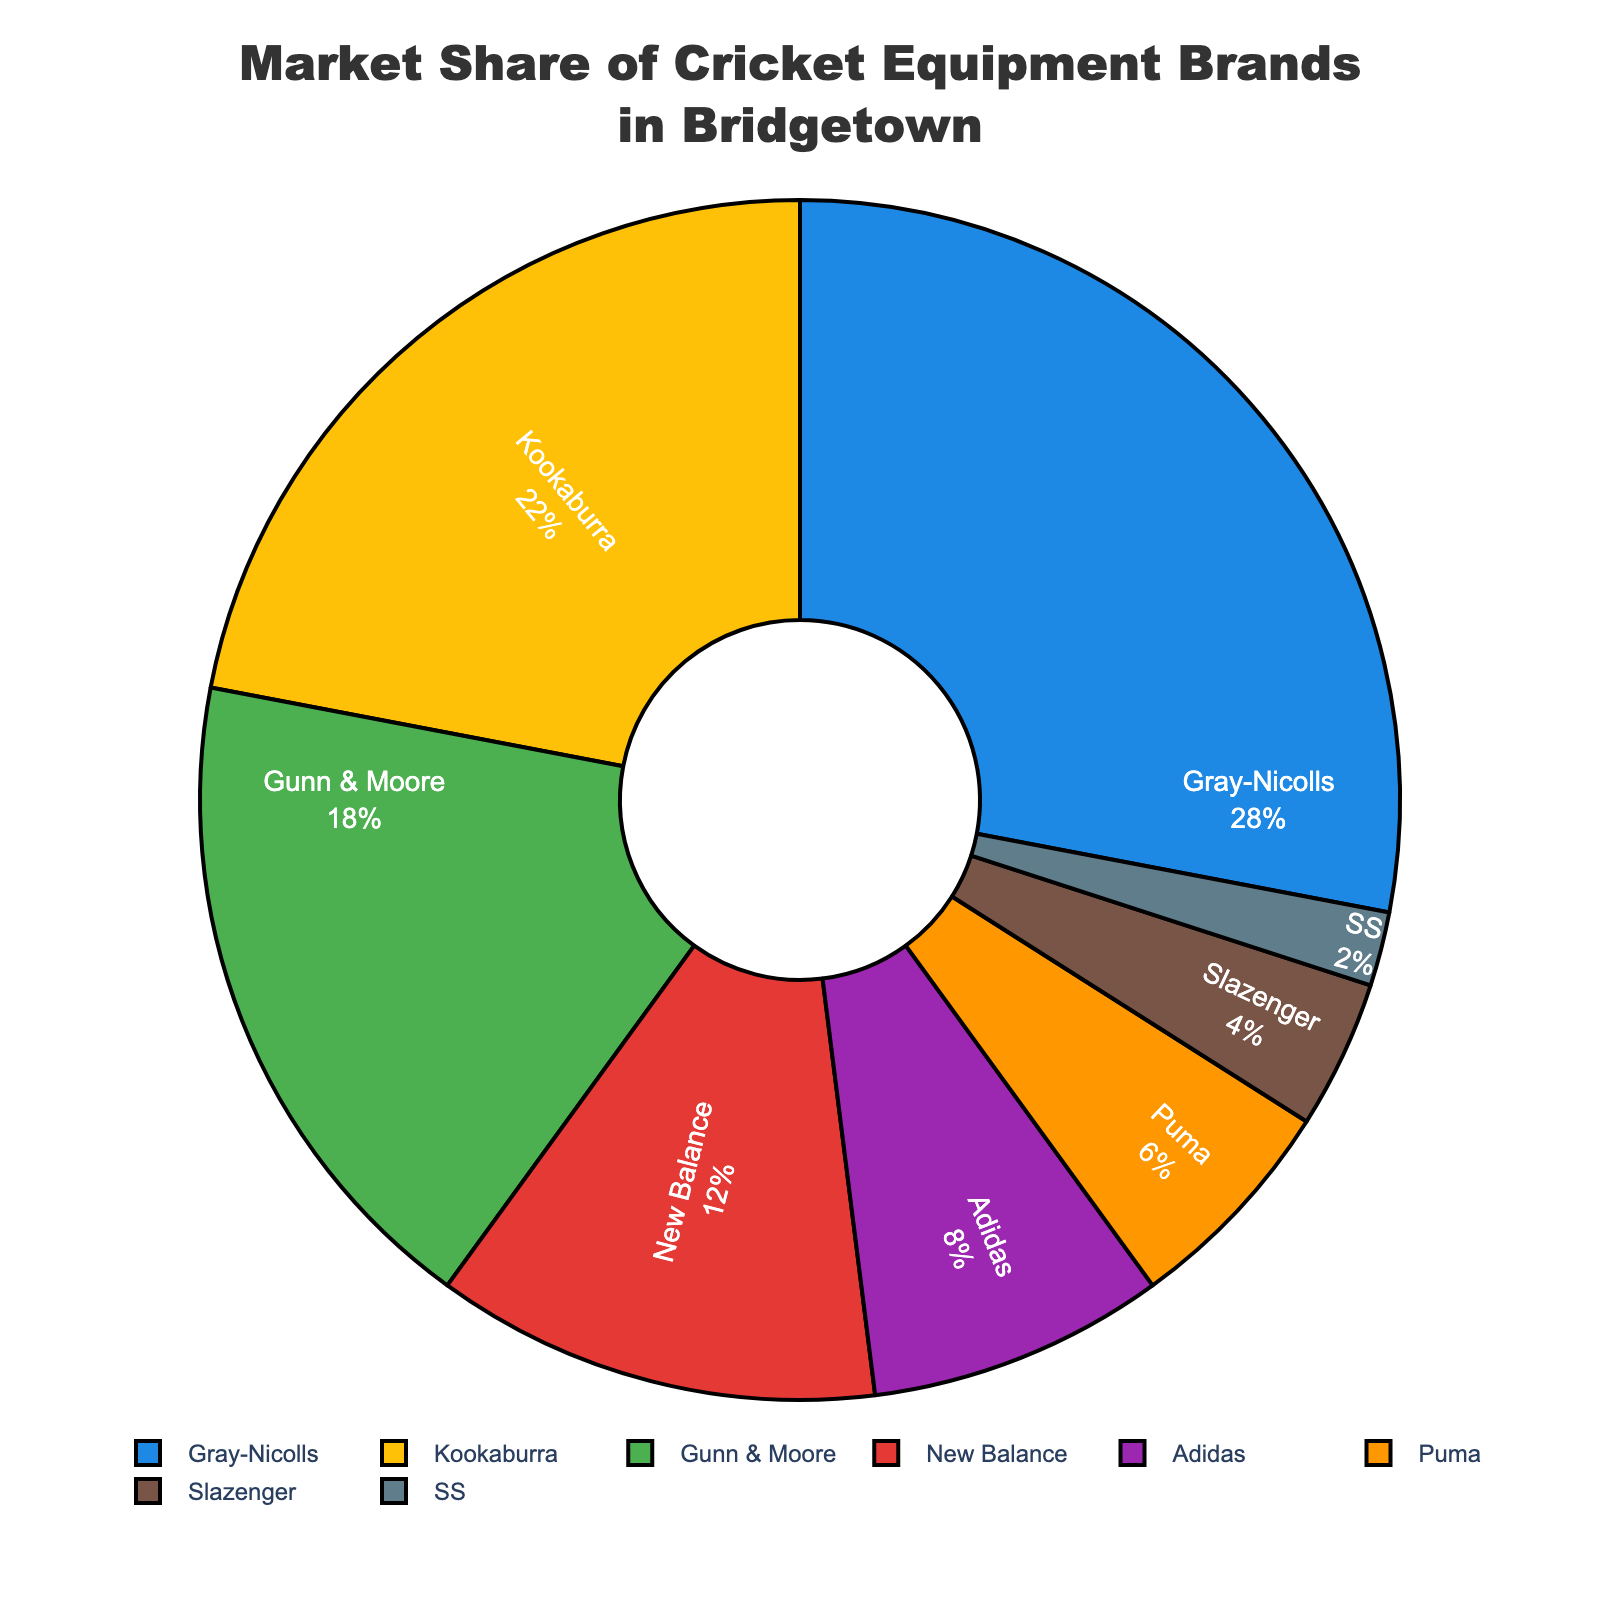Which brand has the highest market share? The chart shows different brands with their market shares. The brand with the largest segment is Gray-Nicolls.
Answer: Gray-Nicolls Which two brands have the lowest market shares? The pie chart shows each brand's share of the market, the two smallest segments represent SS and Slazenger.
Answer: SS and Slazenger How much greater is the market share of Gray-Nicolls compared to Kookaburra? Gray-Nicolls has 28% and Kookaburra has 22%. The difference is 28 - 22 = 6.
Answer: 6% Which brand has a market share twice as large as Adidas? Adidas has 8%. The brand with a market share twice that is 8% * 2 = 16%, which is Gunn & Moore at 18% (close but not exact).
Answer: Gunn & Moore How much market share do the top three brands hold together? The top three brands are Gray-Nicolls (28%), Kookaburra (22%), and Gunn & Moore (18%). The total is 28 + 22 + 18 = 68.
Answer: 68% Which brand is represented by the orange segment in the pie chart? By checking the visual attributes and the legend, the orange segment is assigned to Puma.
Answer: Puma Do Adidas and New Balance together hold more than Kookaburra? Adidas has 8% and New Balance has 12%, together they make 8 + 12 = 20%, while Kookaburra has 22%. 20% is less than 22%.
Answer: No What is the sum of the market shares of brands with less than 10%? The brands with less than 10% are Adidas (8%), Puma (6%), Slazenger (4%), and SS (2%). The sum is 8 + 6 + 4 + 2 = 20.
Answer: 20% Which brand has a market share closest to 1/5 of the total market? 1/5 of 100% is 20%. Kookaburra has a market share of 22%, which is the closest to 20%.
Answer: Kookaburra What is the approximate market share percentage difference between New Balance and Adidas? New Balance has 12% and Adidas has 8%. The difference is 12 - 8 = 4.
Answer: 4% 